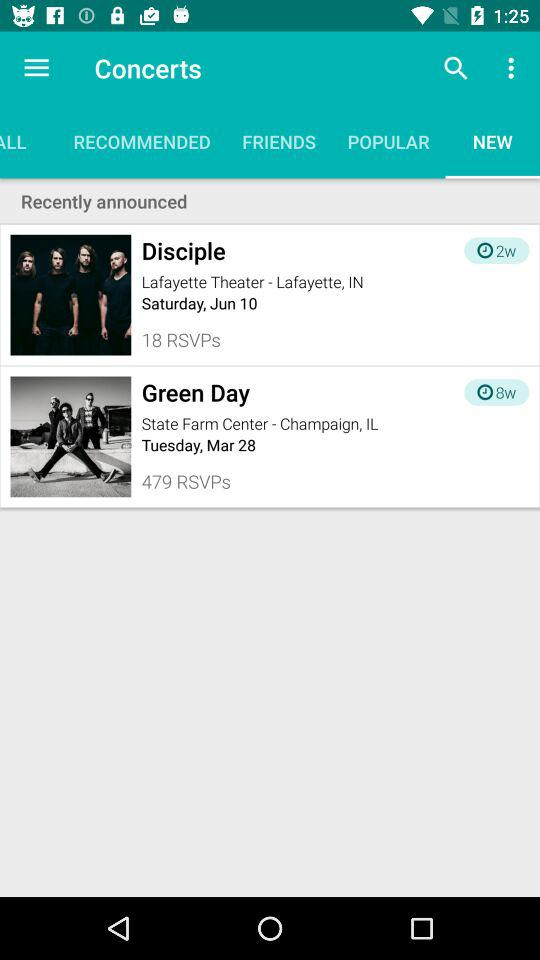What is the selected date for the concert "Green Day"? The date for the concert is Tuesday, March 28. 